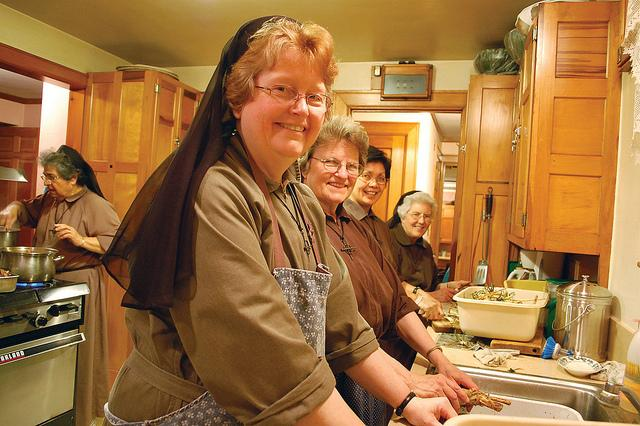What profession are these women in? nuns 